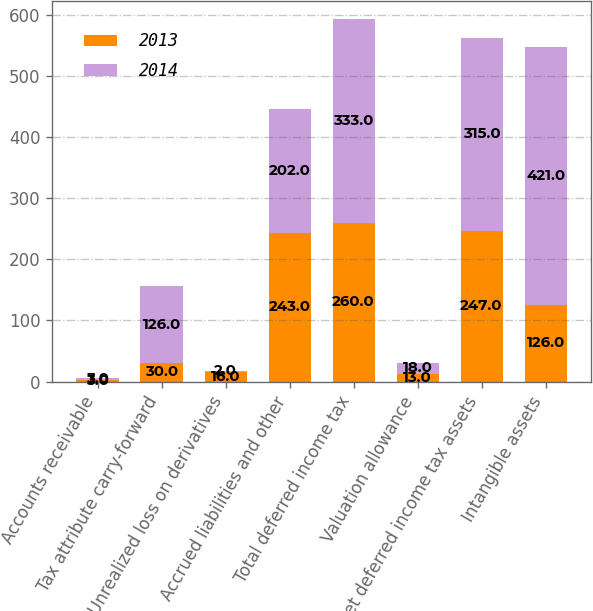<chart> <loc_0><loc_0><loc_500><loc_500><stacked_bar_chart><ecel><fcel>Accounts receivable<fcel>Tax attribute carry-forward<fcel>Unrealized loss on derivatives<fcel>Accrued liabilities and other<fcel>Total deferred income tax<fcel>Valuation allowance<fcel>Net deferred income tax assets<fcel>Intangible assets<nl><fcel>2013<fcel>3<fcel>30<fcel>16<fcel>243<fcel>260<fcel>13<fcel>247<fcel>126<nl><fcel>2014<fcel>3<fcel>126<fcel>2<fcel>202<fcel>333<fcel>18<fcel>315<fcel>421<nl></chart> 